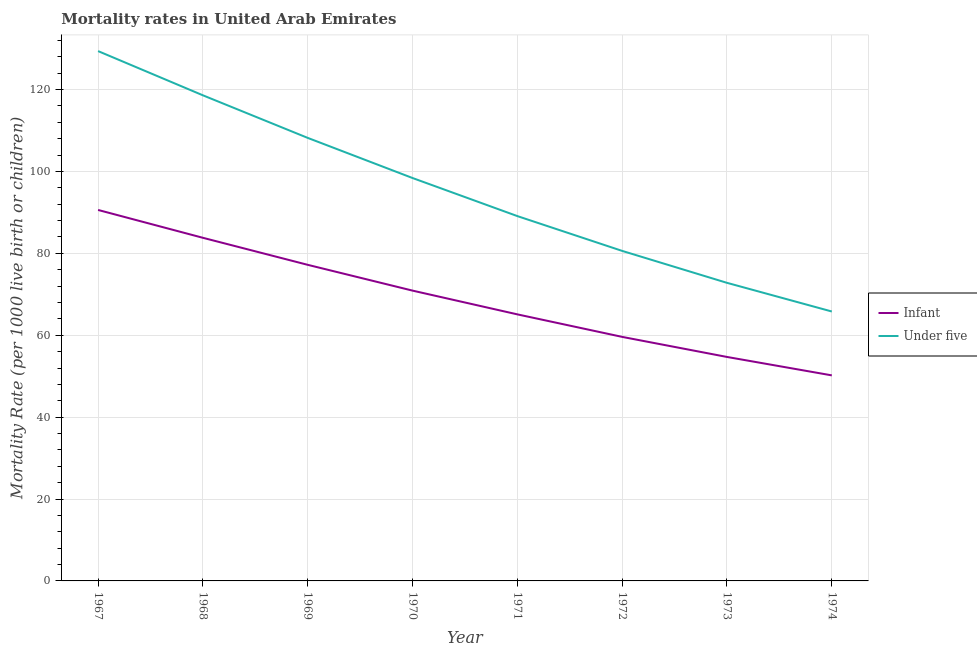Does the line corresponding to infant mortality rate intersect with the line corresponding to under-5 mortality rate?
Offer a terse response. No. Is the number of lines equal to the number of legend labels?
Give a very brief answer. Yes. What is the under-5 mortality rate in 1973?
Provide a succinct answer. 72.8. Across all years, what is the maximum infant mortality rate?
Your answer should be compact. 90.6. Across all years, what is the minimum infant mortality rate?
Make the answer very short. 50.2. In which year was the infant mortality rate maximum?
Keep it short and to the point. 1967. In which year was the under-5 mortality rate minimum?
Offer a very short reply. 1974. What is the total under-5 mortality rate in the graph?
Give a very brief answer. 762.9. What is the difference between the infant mortality rate in 1968 and that in 1970?
Give a very brief answer. 12.9. What is the difference between the infant mortality rate in 1974 and the under-5 mortality rate in 1972?
Make the answer very short. -30.4. What is the average under-5 mortality rate per year?
Your response must be concise. 95.36. In the year 1973, what is the difference between the under-5 mortality rate and infant mortality rate?
Your response must be concise. 18.1. What is the ratio of the under-5 mortality rate in 1970 to that in 1973?
Your answer should be compact. 1.35. Is the difference between the infant mortality rate in 1967 and 1969 greater than the difference between the under-5 mortality rate in 1967 and 1969?
Ensure brevity in your answer.  No. What is the difference between the highest and the second highest under-5 mortality rate?
Your answer should be compact. 10.8. What is the difference between the highest and the lowest infant mortality rate?
Offer a very short reply. 40.4. In how many years, is the infant mortality rate greater than the average infant mortality rate taken over all years?
Provide a short and direct response. 4. Is the under-5 mortality rate strictly less than the infant mortality rate over the years?
Offer a terse response. No. How many lines are there?
Your answer should be very brief. 2. What is the difference between two consecutive major ticks on the Y-axis?
Make the answer very short. 20. Does the graph contain grids?
Your answer should be very brief. Yes. Where does the legend appear in the graph?
Your answer should be very brief. Center right. How are the legend labels stacked?
Your answer should be very brief. Vertical. What is the title of the graph?
Give a very brief answer. Mortality rates in United Arab Emirates. What is the label or title of the X-axis?
Provide a short and direct response. Year. What is the label or title of the Y-axis?
Your answer should be compact. Mortality Rate (per 1000 live birth or children). What is the Mortality Rate (per 1000 live birth or children) of Infant in 1967?
Give a very brief answer. 90.6. What is the Mortality Rate (per 1000 live birth or children) of Under five in 1967?
Your answer should be compact. 129.4. What is the Mortality Rate (per 1000 live birth or children) of Infant in 1968?
Give a very brief answer. 83.8. What is the Mortality Rate (per 1000 live birth or children) in Under five in 1968?
Provide a succinct answer. 118.6. What is the Mortality Rate (per 1000 live birth or children) in Infant in 1969?
Give a very brief answer. 77.2. What is the Mortality Rate (per 1000 live birth or children) of Under five in 1969?
Provide a short and direct response. 108.2. What is the Mortality Rate (per 1000 live birth or children) in Infant in 1970?
Make the answer very short. 70.9. What is the Mortality Rate (per 1000 live birth or children) in Under five in 1970?
Your answer should be compact. 98.4. What is the Mortality Rate (per 1000 live birth or children) in Infant in 1971?
Ensure brevity in your answer.  65.1. What is the Mortality Rate (per 1000 live birth or children) in Under five in 1971?
Provide a short and direct response. 89.1. What is the Mortality Rate (per 1000 live birth or children) of Infant in 1972?
Provide a short and direct response. 59.6. What is the Mortality Rate (per 1000 live birth or children) in Under five in 1972?
Provide a short and direct response. 80.6. What is the Mortality Rate (per 1000 live birth or children) of Infant in 1973?
Give a very brief answer. 54.7. What is the Mortality Rate (per 1000 live birth or children) of Under five in 1973?
Your answer should be very brief. 72.8. What is the Mortality Rate (per 1000 live birth or children) in Infant in 1974?
Provide a succinct answer. 50.2. What is the Mortality Rate (per 1000 live birth or children) in Under five in 1974?
Offer a terse response. 65.8. Across all years, what is the maximum Mortality Rate (per 1000 live birth or children) in Infant?
Give a very brief answer. 90.6. Across all years, what is the maximum Mortality Rate (per 1000 live birth or children) of Under five?
Give a very brief answer. 129.4. Across all years, what is the minimum Mortality Rate (per 1000 live birth or children) of Infant?
Offer a very short reply. 50.2. Across all years, what is the minimum Mortality Rate (per 1000 live birth or children) of Under five?
Provide a short and direct response. 65.8. What is the total Mortality Rate (per 1000 live birth or children) of Infant in the graph?
Make the answer very short. 552.1. What is the total Mortality Rate (per 1000 live birth or children) in Under five in the graph?
Make the answer very short. 762.9. What is the difference between the Mortality Rate (per 1000 live birth or children) of Under five in 1967 and that in 1969?
Your answer should be very brief. 21.2. What is the difference between the Mortality Rate (per 1000 live birth or children) in Infant in 1967 and that in 1970?
Provide a short and direct response. 19.7. What is the difference between the Mortality Rate (per 1000 live birth or children) of Under five in 1967 and that in 1971?
Keep it short and to the point. 40.3. What is the difference between the Mortality Rate (per 1000 live birth or children) in Under five in 1967 and that in 1972?
Give a very brief answer. 48.8. What is the difference between the Mortality Rate (per 1000 live birth or children) in Infant in 1967 and that in 1973?
Ensure brevity in your answer.  35.9. What is the difference between the Mortality Rate (per 1000 live birth or children) in Under five in 1967 and that in 1973?
Provide a succinct answer. 56.6. What is the difference between the Mortality Rate (per 1000 live birth or children) in Infant in 1967 and that in 1974?
Give a very brief answer. 40.4. What is the difference between the Mortality Rate (per 1000 live birth or children) in Under five in 1967 and that in 1974?
Offer a very short reply. 63.6. What is the difference between the Mortality Rate (per 1000 live birth or children) in Under five in 1968 and that in 1970?
Keep it short and to the point. 20.2. What is the difference between the Mortality Rate (per 1000 live birth or children) of Infant in 1968 and that in 1971?
Provide a short and direct response. 18.7. What is the difference between the Mortality Rate (per 1000 live birth or children) in Under five in 1968 and that in 1971?
Offer a terse response. 29.5. What is the difference between the Mortality Rate (per 1000 live birth or children) of Infant in 1968 and that in 1972?
Keep it short and to the point. 24.2. What is the difference between the Mortality Rate (per 1000 live birth or children) in Infant in 1968 and that in 1973?
Your answer should be very brief. 29.1. What is the difference between the Mortality Rate (per 1000 live birth or children) of Under five in 1968 and that in 1973?
Give a very brief answer. 45.8. What is the difference between the Mortality Rate (per 1000 live birth or children) of Infant in 1968 and that in 1974?
Offer a terse response. 33.6. What is the difference between the Mortality Rate (per 1000 live birth or children) in Under five in 1968 and that in 1974?
Keep it short and to the point. 52.8. What is the difference between the Mortality Rate (per 1000 live birth or children) of Under five in 1969 and that in 1970?
Keep it short and to the point. 9.8. What is the difference between the Mortality Rate (per 1000 live birth or children) of Under five in 1969 and that in 1971?
Your response must be concise. 19.1. What is the difference between the Mortality Rate (per 1000 live birth or children) in Under five in 1969 and that in 1972?
Your response must be concise. 27.6. What is the difference between the Mortality Rate (per 1000 live birth or children) of Infant in 1969 and that in 1973?
Make the answer very short. 22.5. What is the difference between the Mortality Rate (per 1000 live birth or children) in Under five in 1969 and that in 1973?
Make the answer very short. 35.4. What is the difference between the Mortality Rate (per 1000 live birth or children) of Under five in 1969 and that in 1974?
Ensure brevity in your answer.  42.4. What is the difference between the Mortality Rate (per 1000 live birth or children) of Infant in 1970 and that in 1971?
Ensure brevity in your answer.  5.8. What is the difference between the Mortality Rate (per 1000 live birth or children) of Infant in 1970 and that in 1973?
Ensure brevity in your answer.  16.2. What is the difference between the Mortality Rate (per 1000 live birth or children) of Under five in 1970 and that in 1973?
Make the answer very short. 25.6. What is the difference between the Mortality Rate (per 1000 live birth or children) of Infant in 1970 and that in 1974?
Offer a very short reply. 20.7. What is the difference between the Mortality Rate (per 1000 live birth or children) of Under five in 1970 and that in 1974?
Offer a very short reply. 32.6. What is the difference between the Mortality Rate (per 1000 live birth or children) in Infant in 1971 and that in 1972?
Keep it short and to the point. 5.5. What is the difference between the Mortality Rate (per 1000 live birth or children) of Infant in 1971 and that in 1973?
Make the answer very short. 10.4. What is the difference between the Mortality Rate (per 1000 live birth or children) in Under five in 1971 and that in 1974?
Your answer should be very brief. 23.3. What is the difference between the Mortality Rate (per 1000 live birth or children) in Infant in 1973 and that in 1974?
Provide a succinct answer. 4.5. What is the difference between the Mortality Rate (per 1000 live birth or children) of Infant in 1967 and the Mortality Rate (per 1000 live birth or children) of Under five in 1968?
Keep it short and to the point. -28. What is the difference between the Mortality Rate (per 1000 live birth or children) in Infant in 1967 and the Mortality Rate (per 1000 live birth or children) in Under five in 1969?
Your answer should be compact. -17.6. What is the difference between the Mortality Rate (per 1000 live birth or children) in Infant in 1967 and the Mortality Rate (per 1000 live birth or children) in Under five in 1970?
Offer a very short reply. -7.8. What is the difference between the Mortality Rate (per 1000 live birth or children) in Infant in 1967 and the Mortality Rate (per 1000 live birth or children) in Under five in 1971?
Your answer should be very brief. 1.5. What is the difference between the Mortality Rate (per 1000 live birth or children) of Infant in 1967 and the Mortality Rate (per 1000 live birth or children) of Under five in 1972?
Offer a terse response. 10. What is the difference between the Mortality Rate (per 1000 live birth or children) of Infant in 1967 and the Mortality Rate (per 1000 live birth or children) of Under five in 1973?
Offer a terse response. 17.8. What is the difference between the Mortality Rate (per 1000 live birth or children) in Infant in 1967 and the Mortality Rate (per 1000 live birth or children) in Under five in 1974?
Give a very brief answer. 24.8. What is the difference between the Mortality Rate (per 1000 live birth or children) in Infant in 1968 and the Mortality Rate (per 1000 live birth or children) in Under five in 1969?
Keep it short and to the point. -24.4. What is the difference between the Mortality Rate (per 1000 live birth or children) in Infant in 1968 and the Mortality Rate (per 1000 live birth or children) in Under five in 1970?
Your answer should be compact. -14.6. What is the difference between the Mortality Rate (per 1000 live birth or children) of Infant in 1968 and the Mortality Rate (per 1000 live birth or children) of Under five in 1971?
Your response must be concise. -5.3. What is the difference between the Mortality Rate (per 1000 live birth or children) in Infant in 1968 and the Mortality Rate (per 1000 live birth or children) in Under five in 1973?
Your answer should be very brief. 11. What is the difference between the Mortality Rate (per 1000 live birth or children) of Infant in 1969 and the Mortality Rate (per 1000 live birth or children) of Under five in 1970?
Make the answer very short. -21.2. What is the difference between the Mortality Rate (per 1000 live birth or children) of Infant in 1969 and the Mortality Rate (per 1000 live birth or children) of Under five in 1972?
Provide a succinct answer. -3.4. What is the difference between the Mortality Rate (per 1000 live birth or children) in Infant in 1969 and the Mortality Rate (per 1000 live birth or children) in Under five in 1973?
Keep it short and to the point. 4.4. What is the difference between the Mortality Rate (per 1000 live birth or children) in Infant in 1970 and the Mortality Rate (per 1000 live birth or children) in Under five in 1971?
Provide a succinct answer. -18.2. What is the difference between the Mortality Rate (per 1000 live birth or children) in Infant in 1970 and the Mortality Rate (per 1000 live birth or children) in Under five in 1972?
Offer a very short reply. -9.7. What is the difference between the Mortality Rate (per 1000 live birth or children) in Infant in 1970 and the Mortality Rate (per 1000 live birth or children) in Under five in 1973?
Your response must be concise. -1.9. What is the difference between the Mortality Rate (per 1000 live birth or children) of Infant in 1970 and the Mortality Rate (per 1000 live birth or children) of Under five in 1974?
Give a very brief answer. 5.1. What is the difference between the Mortality Rate (per 1000 live birth or children) of Infant in 1971 and the Mortality Rate (per 1000 live birth or children) of Under five in 1972?
Ensure brevity in your answer.  -15.5. What is the difference between the Mortality Rate (per 1000 live birth or children) in Infant in 1971 and the Mortality Rate (per 1000 live birth or children) in Under five in 1974?
Your answer should be compact. -0.7. What is the average Mortality Rate (per 1000 live birth or children) in Infant per year?
Ensure brevity in your answer.  69.01. What is the average Mortality Rate (per 1000 live birth or children) of Under five per year?
Provide a succinct answer. 95.36. In the year 1967, what is the difference between the Mortality Rate (per 1000 live birth or children) of Infant and Mortality Rate (per 1000 live birth or children) of Under five?
Provide a short and direct response. -38.8. In the year 1968, what is the difference between the Mortality Rate (per 1000 live birth or children) in Infant and Mortality Rate (per 1000 live birth or children) in Under five?
Your response must be concise. -34.8. In the year 1969, what is the difference between the Mortality Rate (per 1000 live birth or children) of Infant and Mortality Rate (per 1000 live birth or children) of Under five?
Provide a succinct answer. -31. In the year 1970, what is the difference between the Mortality Rate (per 1000 live birth or children) of Infant and Mortality Rate (per 1000 live birth or children) of Under five?
Provide a short and direct response. -27.5. In the year 1971, what is the difference between the Mortality Rate (per 1000 live birth or children) in Infant and Mortality Rate (per 1000 live birth or children) in Under five?
Provide a short and direct response. -24. In the year 1973, what is the difference between the Mortality Rate (per 1000 live birth or children) in Infant and Mortality Rate (per 1000 live birth or children) in Under five?
Ensure brevity in your answer.  -18.1. In the year 1974, what is the difference between the Mortality Rate (per 1000 live birth or children) of Infant and Mortality Rate (per 1000 live birth or children) of Under five?
Your answer should be compact. -15.6. What is the ratio of the Mortality Rate (per 1000 live birth or children) of Infant in 1967 to that in 1968?
Make the answer very short. 1.08. What is the ratio of the Mortality Rate (per 1000 live birth or children) in Under five in 1967 to that in 1968?
Ensure brevity in your answer.  1.09. What is the ratio of the Mortality Rate (per 1000 live birth or children) in Infant in 1967 to that in 1969?
Ensure brevity in your answer.  1.17. What is the ratio of the Mortality Rate (per 1000 live birth or children) in Under five in 1967 to that in 1969?
Provide a succinct answer. 1.2. What is the ratio of the Mortality Rate (per 1000 live birth or children) of Infant in 1967 to that in 1970?
Your response must be concise. 1.28. What is the ratio of the Mortality Rate (per 1000 live birth or children) of Under five in 1967 to that in 1970?
Your answer should be compact. 1.31. What is the ratio of the Mortality Rate (per 1000 live birth or children) of Infant in 1967 to that in 1971?
Your response must be concise. 1.39. What is the ratio of the Mortality Rate (per 1000 live birth or children) in Under five in 1967 to that in 1971?
Make the answer very short. 1.45. What is the ratio of the Mortality Rate (per 1000 live birth or children) in Infant in 1967 to that in 1972?
Your answer should be very brief. 1.52. What is the ratio of the Mortality Rate (per 1000 live birth or children) of Under five in 1967 to that in 1972?
Your response must be concise. 1.61. What is the ratio of the Mortality Rate (per 1000 live birth or children) of Infant in 1967 to that in 1973?
Offer a terse response. 1.66. What is the ratio of the Mortality Rate (per 1000 live birth or children) of Under five in 1967 to that in 1973?
Keep it short and to the point. 1.78. What is the ratio of the Mortality Rate (per 1000 live birth or children) of Infant in 1967 to that in 1974?
Make the answer very short. 1.8. What is the ratio of the Mortality Rate (per 1000 live birth or children) in Under five in 1967 to that in 1974?
Make the answer very short. 1.97. What is the ratio of the Mortality Rate (per 1000 live birth or children) in Infant in 1968 to that in 1969?
Give a very brief answer. 1.09. What is the ratio of the Mortality Rate (per 1000 live birth or children) in Under five in 1968 to that in 1969?
Make the answer very short. 1.1. What is the ratio of the Mortality Rate (per 1000 live birth or children) of Infant in 1968 to that in 1970?
Your answer should be very brief. 1.18. What is the ratio of the Mortality Rate (per 1000 live birth or children) of Under five in 1968 to that in 1970?
Provide a short and direct response. 1.21. What is the ratio of the Mortality Rate (per 1000 live birth or children) of Infant in 1968 to that in 1971?
Provide a short and direct response. 1.29. What is the ratio of the Mortality Rate (per 1000 live birth or children) in Under five in 1968 to that in 1971?
Your response must be concise. 1.33. What is the ratio of the Mortality Rate (per 1000 live birth or children) in Infant in 1968 to that in 1972?
Give a very brief answer. 1.41. What is the ratio of the Mortality Rate (per 1000 live birth or children) in Under five in 1968 to that in 1972?
Your answer should be very brief. 1.47. What is the ratio of the Mortality Rate (per 1000 live birth or children) of Infant in 1968 to that in 1973?
Make the answer very short. 1.53. What is the ratio of the Mortality Rate (per 1000 live birth or children) in Under five in 1968 to that in 1973?
Offer a very short reply. 1.63. What is the ratio of the Mortality Rate (per 1000 live birth or children) in Infant in 1968 to that in 1974?
Your answer should be very brief. 1.67. What is the ratio of the Mortality Rate (per 1000 live birth or children) in Under five in 1968 to that in 1974?
Provide a succinct answer. 1.8. What is the ratio of the Mortality Rate (per 1000 live birth or children) in Infant in 1969 to that in 1970?
Your response must be concise. 1.09. What is the ratio of the Mortality Rate (per 1000 live birth or children) of Under five in 1969 to that in 1970?
Your response must be concise. 1.1. What is the ratio of the Mortality Rate (per 1000 live birth or children) of Infant in 1969 to that in 1971?
Offer a very short reply. 1.19. What is the ratio of the Mortality Rate (per 1000 live birth or children) of Under five in 1969 to that in 1971?
Keep it short and to the point. 1.21. What is the ratio of the Mortality Rate (per 1000 live birth or children) in Infant in 1969 to that in 1972?
Provide a short and direct response. 1.3. What is the ratio of the Mortality Rate (per 1000 live birth or children) in Under five in 1969 to that in 1972?
Make the answer very short. 1.34. What is the ratio of the Mortality Rate (per 1000 live birth or children) in Infant in 1969 to that in 1973?
Offer a terse response. 1.41. What is the ratio of the Mortality Rate (per 1000 live birth or children) in Under five in 1969 to that in 1973?
Make the answer very short. 1.49. What is the ratio of the Mortality Rate (per 1000 live birth or children) of Infant in 1969 to that in 1974?
Your answer should be compact. 1.54. What is the ratio of the Mortality Rate (per 1000 live birth or children) of Under five in 1969 to that in 1974?
Give a very brief answer. 1.64. What is the ratio of the Mortality Rate (per 1000 live birth or children) in Infant in 1970 to that in 1971?
Provide a succinct answer. 1.09. What is the ratio of the Mortality Rate (per 1000 live birth or children) of Under five in 1970 to that in 1971?
Give a very brief answer. 1.1. What is the ratio of the Mortality Rate (per 1000 live birth or children) of Infant in 1970 to that in 1972?
Keep it short and to the point. 1.19. What is the ratio of the Mortality Rate (per 1000 live birth or children) of Under five in 1970 to that in 1972?
Keep it short and to the point. 1.22. What is the ratio of the Mortality Rate (per 1000 live birth or children) of Infant in 1970 to that in 1973?
Provide a short and direct response. 1.3. What is the ratio of the Mortality Rate (per 1000 live birth or children) of Under five in 1970 to that in 1973?
Ensure brevity in your answer.  1.35. What is the ratio of the Mortality Rate (per 1000 live birth or children) in Infant in 1970 to that in 1974?
Provide a short and direct response. 1.41. What is the ratio of the Mortality Rate (per 1000 live birth or children) of Under five in 1970 to that in 1974?
Give a very brief answer. 1.5. What is the ratio of the Mortality Rate (per 1000 live birth or children) of Infant in 1971 to that in 1972?
Keep it short and to the point. 1.09. What is the ratio of the Mortality Rate (per 1000 live birth or children) in Under five in 1971 to that in 1972?
Provide a succinct answer. 1.11. What is the ratio of the Mortality Rate (per 1000 live birth or children) of Infant in 1971 to that in 1973?
Your response must be concise. 1.19. What is the ratio of the Mortality Rate (per 1000 live birth or children) of Under five in 1971 to that in 1973?
Ensure brevity in your answer.  1.22. What is the ratio of the Mortality Rate (per 1000 live birth or children) of Infant in 1971 to that in 1974?
Keep it short and to the point. 1.3. What is the ratio of the Mortality Rate (per 1000 live birth or children) in Under five in 1971 to that in 1974?
Provide a succinct answer. 1.35. What is the ratio of the Mortality Rate (per 1000 live birth or children) of Infant in 1972 to that in 1973?
Make the answer very short. 1.09. What is the ratio of the Mortality Rate (per 1000 live birth or children) of Under five in 1972 to that in 1973?
Give a very brief answer. 1.11. What is the ratio of the Mortality Rate (per 1000 live birth or children) in Infant in 1972 to that in 1974?
Make the answer very short. 1.19. What is the ratio of the Mortality Rate (per 1000 live birth or children) in Under five in 1972 to that in 1974?
Provide a succinct answer. 1.22. What is the ratio of the Mortality Rate (per 1000 live birth or children) of Infant in 1973 to that in 1974?
Your answer should be compact. 1.09. What is the ratio of the Mortality Rate (per 1000 live birth or children) in Under five in 1973 to that in 1974?
Ensure brevity in your answer.  1.11. What is the difference between the highest and the second highest Mortality Rate (per 1000 live birth or children) of Infant?
Give a very brief answer. 6.8. What is the difference between the highest and the second highest Mortality Rate (per 1000 live birth or children) of Under five?
Your answer should be very brief. 10.8. What is the difference between the highest and the lowest Mortality Rate (per 1000 live birth or children) in Infant?
Make the answer very short. 40.4. What is the difference between the highest and the lowest Mortality Rate (per 1000 live birth or children) in Under five?
Ensure brevity in your answer.  63.6. 